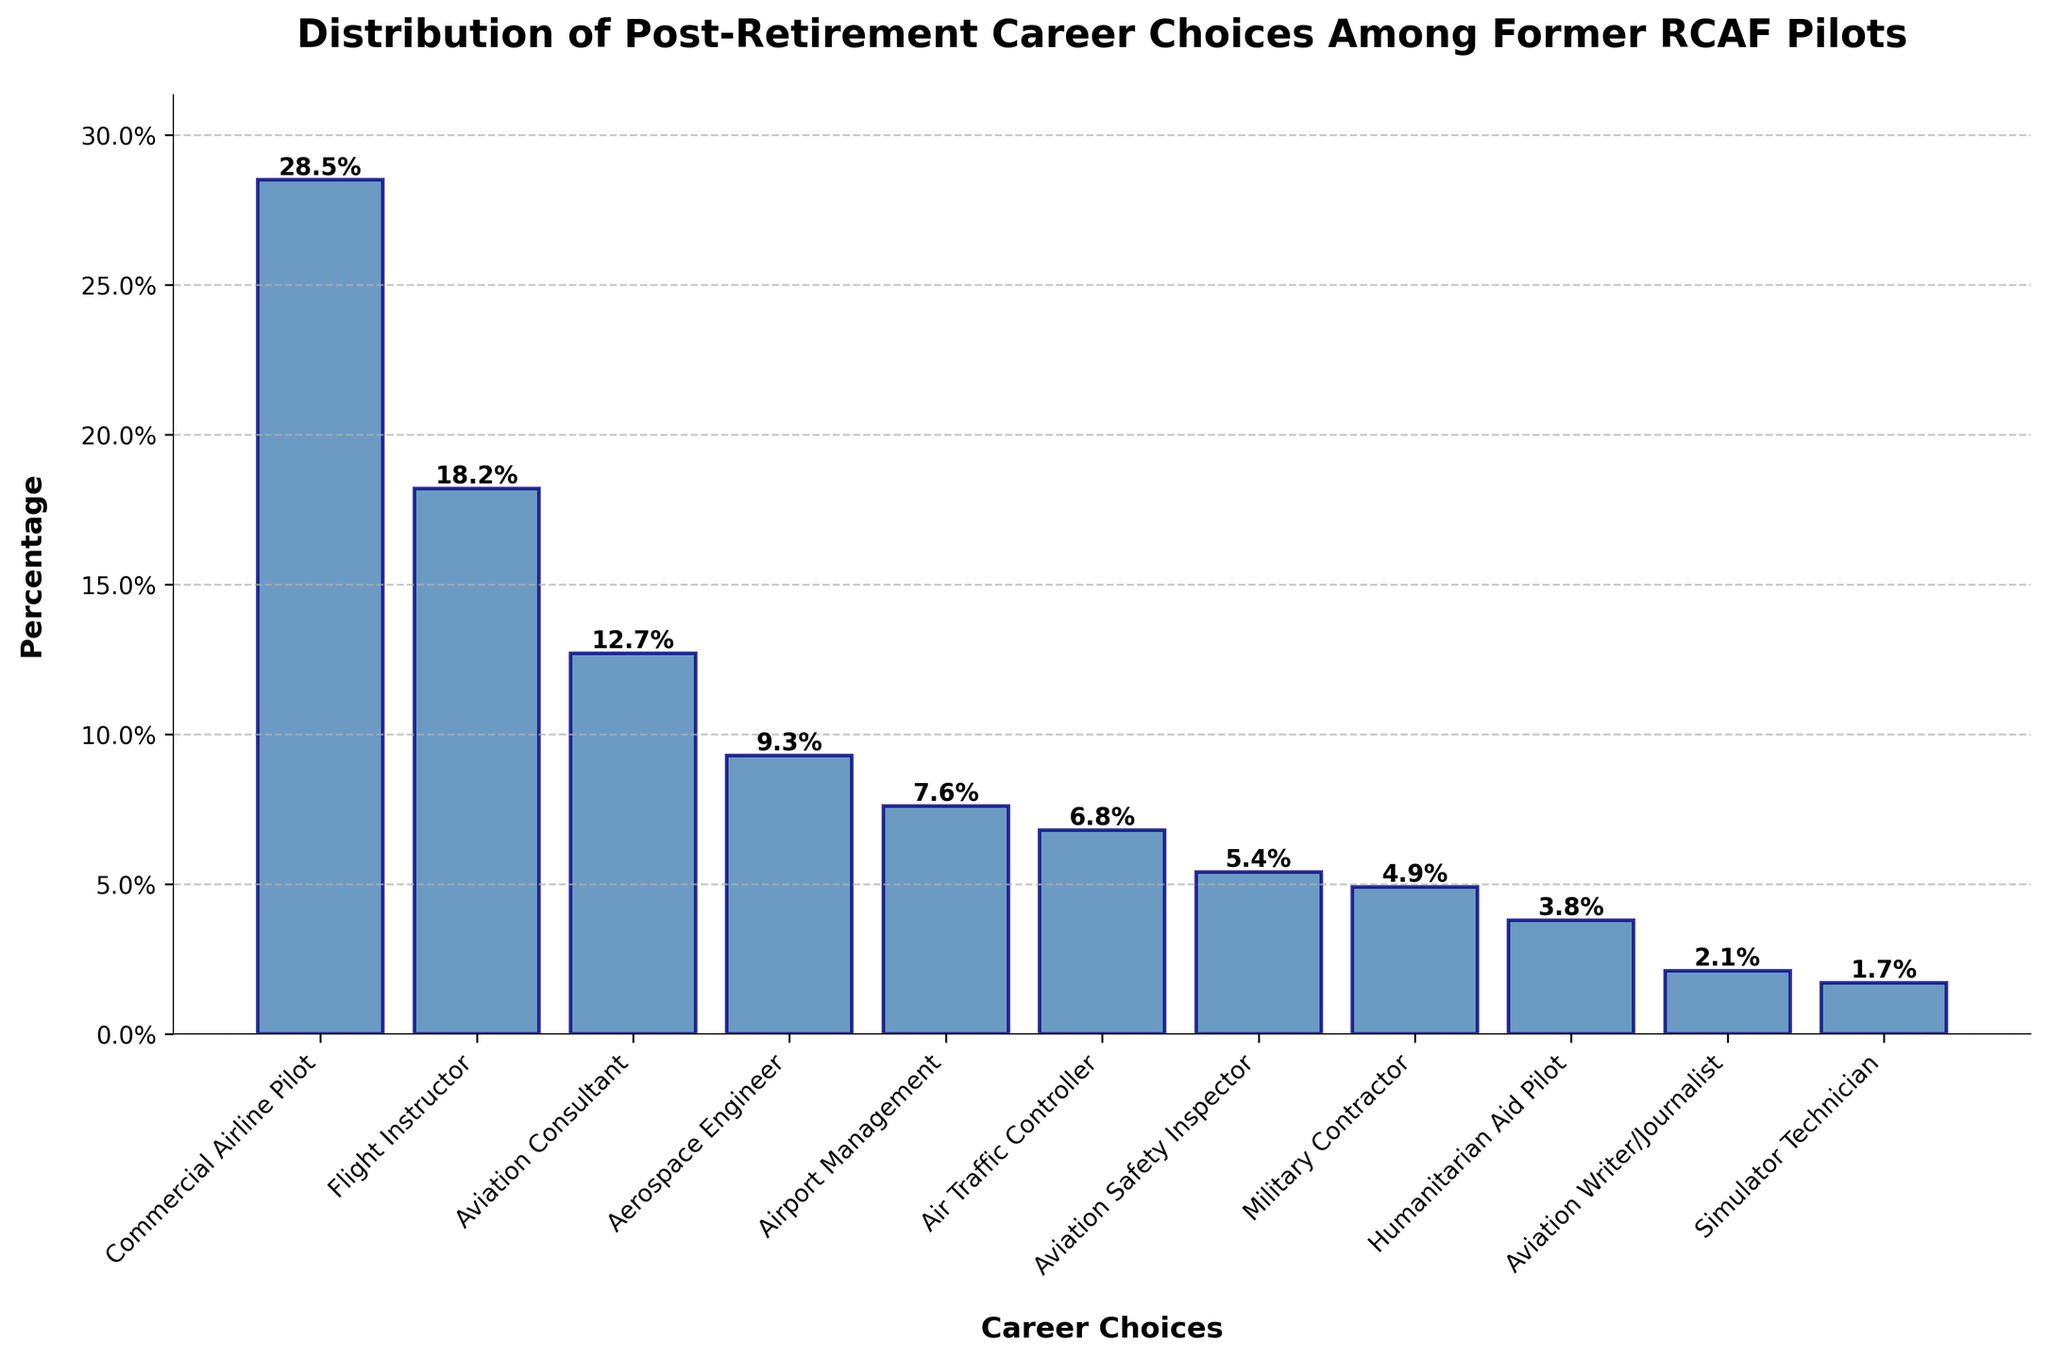What is the most common post-retirement career choice for former RCAF pilots? The bar chart shows that the highest bar corresponds to "Commercial Airline Pilot," indicating it has the highest percentage at 28.5%.
Answer: Commercial Airline Pilot Which career has a higher percentage, Aviation Consultant or Aerospace Engineer? Comparing the heights of the bars for "Aviation Consultant" and "Aerospace Engineer," we see that "Aviation Consultant" is higher at 12.7%, while "Aerospace Engineer" is 9.3%.
Answer: Aviation Consultant What is the total percentage of former RCAF pilots working as Flight Instructors and Aviation Consultants? Add the percentages for "Flight Instructor" (18.2%) and "Aviation Consultant" (12.7%). This gives 18.2 + 12.7 = 30.9%.
Answer: 30.9% What percentage of former RCAF pilots have roles in Airport Management and as Air Traffic Controllers combined? Add the percentages for "Airport Management" (7.6%) and "Air Traffic Controller" (6.8%). This gives 7.6 + 6.8 = 14.4%.
Answer: 14.4% Which career choice is the least popular among former RCAF pilots? The bar chart shows that the shortest bar corresponds to "Simulator Technician," indicating it has the lowest percentage at 1.7%.
Answer: Simulator Technician How does the percentage of Commercial Airline Pilots compare to the combined percentage of Aviation Safety Inspectors and Military Contractors? The percentage for "Commercial Airline Pilot" is 28.5%. The combined percentage for "Aviation Safety Inspector" (5.4%) and "Military Contractor" (4.9%) is 5.4 + 4.9 = 10.3%. Since 28.5% is greater than 10.3%, the percentage of Commercial Airline Pilots is higher.
Answer: Commercial Airline Pilots percentage is higher What is the average percentage of pilots working in roles less than 5%? The roles with percentages less than 5% are "Military Contractor" (4.9%), "Humanitarian Aid Pilot" (3.8%), "Aviation Writer/Journalist" (2.1%), and "Simulator Technician" (1.7%). The sum of these percentages is 4.9 + 3.8 + 2.1 + 1.7 = 12.5%. The average is 12.5 / 4 = 3.13%.
Answer: 3.13% What is the percentage difference between former RCAF pilots working as Commercial Airline Pilots and those working as Aviation Safety Inspectors? The percentage for "Commercial Airline Pilot" is 28.5%, and for "Aviation Safety Inspector" is 5.4%. The difference is 28.5 - 5.4 = 23.1%.
Answer: 23.1% Which has a higher percentage, Flight Instructor or the combined percentage of Aerospace Engineers and Airport Management? The percentage for "Flight Instructor" is 18.2%. The combined percentage for "Aerospace Engineer" (9.3%) and "Airport Management" (7.6%) is 9.3 + 7.6 = 16.9%. Since 18.2% is greater than 16.9%, the percentage of Flight Instructors is higher.
Answer: Flight Instructor What is the sum of the percentages of the three least common career choices? The three least common career choices are "Simulator Technician" (1.7%), "Aviation Writer/Journalist" (2.1%), and "Humanitarian Aid Pilot" (3.8%). Their sum is 1.7 + 2.1 + 3.8 = 7.6%.
Answer: 7.6% 